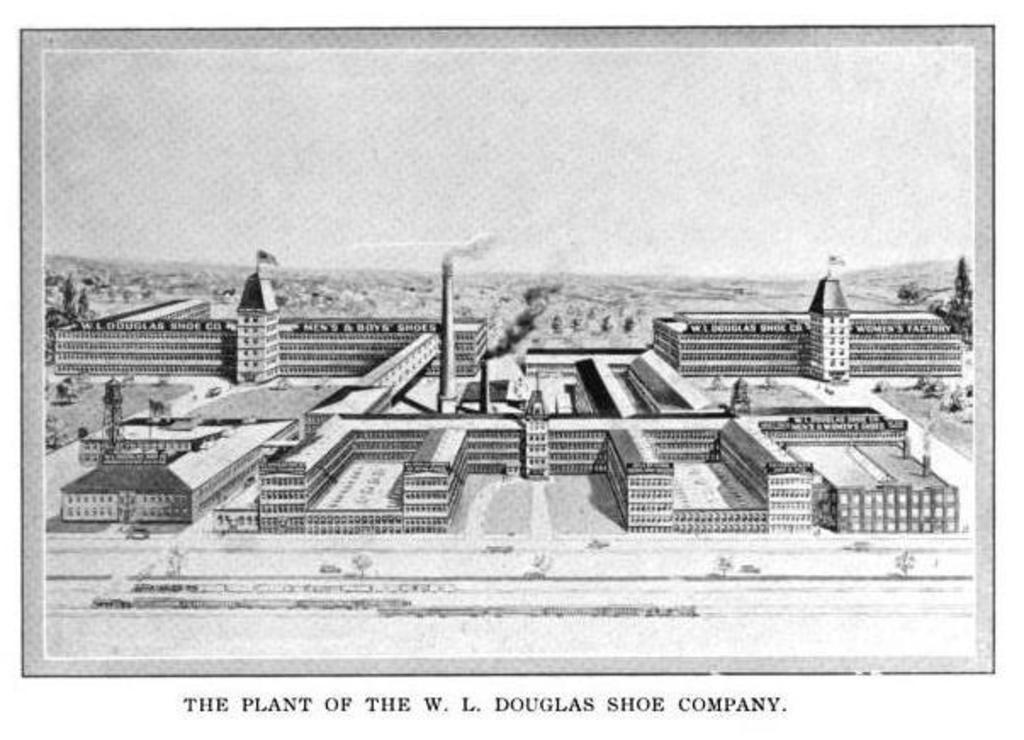Can you describe this image briefly? In this image I can see few buildings and the sky and I can see something written on the image and the image is in black and white. 